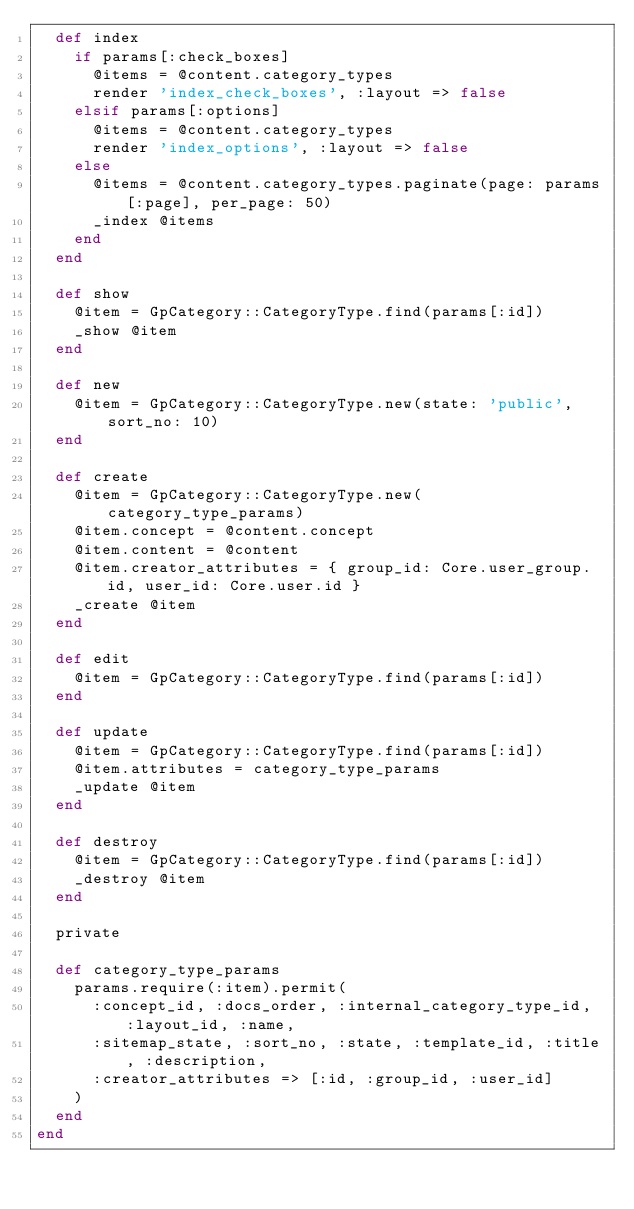<code> <loc_0><loc_0><loc_500><loc_500><_Ruby_>  def index
    if params[:check_boxes]
      @items = @content.category_types
      render 'index_check_boxes', :layout => false
    elsif params[:options]
      @items = @content.category_types
      render 'index_options', :layout => false
    else
      @items = @content.category_types.paginate(page: params[:page], per_page: 50)
      _index @items
    end
  end

  def show
    @item = GpCategory::CategoryType.find(params[:id])
    _show @item
  end

  def new
    @item = GpCategory::CategoryType.new(state: 'public', sort_no: 10)
  end

  def create
    @item = GpCategory::CategoryType.new(category_type_params)
    @item.concept = @content.concept
    @item.content = @content
    @item.creator_attributes = { group_id: Core.user_group.id, user_id: Core.user.id }
    _create @item
  end

  def edit
    @item = GpCategory::CategoryType.find(params[:id])
  end

  def update
    @item = GpCategory::CategoryType.find(params[:id])
    @item.attributes = category_type_params
    _update @item
  end

  def destroy
    @item = GpCategory::CategoryType.find(params[:id])
    _destroy @item
  end

  private

  def category_type_params
    params.require(:item).permit(
      :concept_id, :docs_order, :internal_category_type_id, :layout_id, :name,
      :sitemap_state, :sort_no, :state, :template_id, :title, :description,
      :creator_attributes => [:id, :group_id, :user_id]
    )
  end
end
</code> 